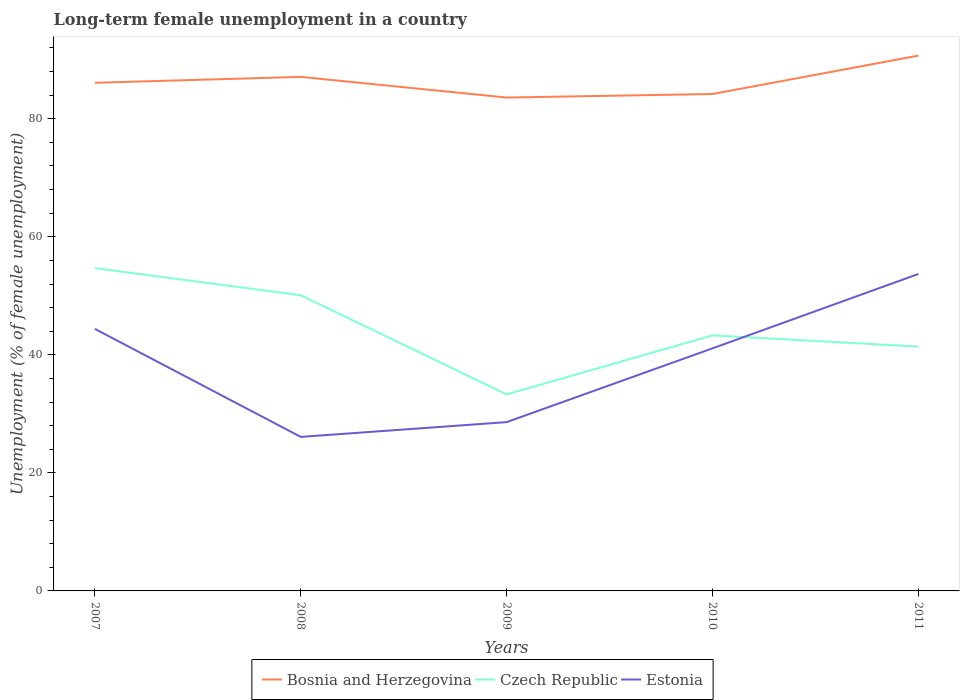Is the number of lines equal to the number of legend labels?
Make the answer very short. Yes. Across all years, what is the maximum percentage of long-term unemployed female population in Czech Republic?
Keep it short and to the point. 33.3. In which year was the percentage of long-term unemployed female population in Bosnia and Herzegovina maximum?
Ensure brevity in your answer.  2009. What is the total percentage of long-term unemployed female population in Estonia in the graph?
Provide a short and direct response. 3.3. What is the difference between the highest and the second highest percentage of long-term unemployed female population in Bosnia and Herzegovina?
Your answer should be compact. 7.1. How many lines are there?
Give a very brief answer. 3. What is the difference between two consecutive major ticks on the Y-axis?
Provide a succinct answer. 20. Are the values on the major ticks of Y-axis written in scientific E-notation?
Make the answer very short. No. Does the graph contain any zero values?
Keep it short and to the point. No. Does the graph contain grids?
Offer a terse response. No. Where does the legend appear in the graph?
Offer a terse response. Bottom center. How many legend labels are there?
Offer a very short reply. 3. How are the legend labels stacked?
Your answer should be compact. Horizontal. What is the title of the graph?
Your response must be concise. Long-term female unemployment in a country. What is the label or title of the Y-axis?
Make the answer very short. Unemployment (% of female unemployment). What is the Unemployment (% of female unemployment) of Bosnia and Herzegovina in 2007?
Provide a short and direct response. 86.1. What is the Unemployment (% of female unemployment) of Czech Republic in 2007?
Provide a succinct answer. 54.7. What is the Unemployment (% of female unemployment) of Estonia in 2007?
Offer a terse response. 44.4. What is the Unemployment (% of female unemployment) of Bosnia and Herzegovina in 2008?
Keep it short and to the point. 87.1. What is the Unemployment (% of female unemployment) in Czech Republic in 2008?
Ensure brevity in your answer.  50.1. What is the Unemployment (% of female unemployment) of Estonia in 2008?
Provide a succinct answer. 26.1. What is the Unemployment (% of female unemployment) in Bosnia and Herzegovina in 2009?
Give a very brief answer. 83.6. What is the Unemployment (% of female unemployment) of Czech Republic in 2009?
Provide a succinct answer. 33.3. What is the Unemployment (% of female unemployment) in Estonia in 2009?
Offer a terse response. 28.6. What is the Unemployment (% of female unemployment) of Bosnia and Herzegovina in 2010?
Provide a short and direct response. 84.2. What is the Unemployment (% of female unemployment) of Czech Republic in 2010?
Provide a short and direct response. 43.3. What is the Unemployment (% of female unemployment) of Estonia in 2010?
Make the answer very short. 41.1. What is the Unemployment (% of female unemployment) in Bosnia and Herzegovina in 2011?
Your response must be concise. 90.7. What is the Unemployment (% of female unemployment) of Czech Republic in 2011?
Provide a succinct answer. 41.4. What is the Unemployment (% of female unemployment) in Estonia in 2011?
Your answer should be compact. 53.7. Across all years, what is the maximum Unemployment (% of female unemployment) of Bosnia and Herzegovina?
Offer a terse response. 90.7. Across all years, what is the maximum Unemployment (% of female unemployment) of Czech Republic?
Offer a terse response. 54.7. Across all years, what is the maximum Unemployment (% of female unemployment) in Estonia?
Offer a terse response. 53.7. Across all years, what is the minimum Unemployment (% of female unemployment) in Bosnia and Herzegovina?
Give a very brief answer. 83.6. Across all years, what is the minimum Unemployment (% of female unemployment) in Czech Republic?
Your response must be concise. 33.3. Across all years, what is the minimum Unemployment (% of female unemployment) in Estonia?
Your response must be concise. 26.1. What is the total Unemployment (% of female unemployment) in Bosnia and Herzegovina in the graph?
Keep it short and to the point. 431.7. What is the total Unemployment (% of female unemployment) of Czech Republic in the graph?
Provide a succinct answer. 222.8. What is the total Unemployment (% of female unemployment) in Estonia in the graph?
Your response must be concise. 193.9. What is the difference between the Unemployment (% of female unemployment) in Bosnia and Herzegovina in 2007 and that in 2008?
Provide a succinct answer. -1. What is the difference between the Unemployment (% of female unemployment) in Czech Republic in 2007 and that in 2008?
Your answer should be compact. 4.6. What is the difference between the Unemployment (% of female unemployment) in Bosnia and Herzegovina in 2007 and that in 2009?
Offer a very short reply. 2.5. What is the difference between the Unemployment (% of female unemployment) of Czech Republic in 2007 and that in 2009?
Make the answer very short. 21.4. What is the difference between the Unemployment (% of female unemployment) of Bosnia and Herzegovina in 2007 and that in 2010?
Your response must be concise. 1.9. What is the difference between the Unemployment (% of female unemployment) of Czech Republic in 2007 and that in 2011?
Ensure brevity in your answer.  13.3. What is the difference between the Unemployment (% of female unemployment) of Bosnia and Herzegovina in 2008 and that in 2009?
Your response must be concise. 3.5. What is the difference between the Unemployment (% of female unemployment) of Czech Republic in 2008 and that in 2009?
Ensure brevity in your answer.  16.8. What is the difference between the Unemployment (% of female unemployment) in Estonia in 2008 and that in 2009?
Give a very brief answer. -2.5. What is the difference between the Unemployment (% of female unemployment) in Bosnia and Herzegovina in 2008 and that in 2010?
Give a very brief answer. 2.9. What is the difference between the Unemployment (% of female unemployment) in Czech Republic in 2008 and that in 2010?
Ensure brevity in your answer.  6.8. What is the difference between the Unemployment (% of female unemployment) in Bosnia and Herzegovina in 2008 and that in 2011?
Your response must be concise. -3.6. What is the difference between the Unemployment (% of female unemployment) of Estonia in 2008 and that in 2011?
Give a very brief answer. -27.6. What is the difference between the Unemployment (% of female unemployment) in Bosnia and Herzegovina in 2009 and that in 2010?
Your response must be concise. -0.6. What is the difference between the Unemployment (% of female unemployment) in Czech Republic in 2009 and that in 2010?
Provide a succinct answer. -10. What is the difference between the Unemployment (% of female unemployment) in Bosnia and Herzegovina in 2009 and that in 2011?
Offer a very short reply. -7.1. What is the difference between the Unemployment (% of female unemployment) of Czech Republic in 2009 and that in 2011?
Offer a very short reply. -8.1. What is the difference between the Unemployment (% of female unemployment) of Estonia in 2009 and that in 2011?
Your answer should be very brief. -25.1. What is the difference between the Unemployment (% of female unemployment) in Bosnia and Herzegovina in 2010 and that in 2011?
Provide a succinct answer. -6.5. What is the difference between the Unemployment (% of female unemployment) in Czech Republic in 2010 and that in 2011?
Provide a short and direct response. 1.9. What is the difference between the Unemployment (% of female unemployment) of Czech Republic in 2007 and the Unemployment (% of female unemployment) of Estonia in 2008?
Keep it short and to the point. 28.6. What is the difference between the Unemployment (% of female unemployment) of Bosnia and Herzegovina in 2007 and the Unemployment (% of female unemployment) of Czech Republic in 2009?
Your answer should be compact. 52.8. What is the difference between the Unemployment (% of female unemployment) of Bosnia and Herzegovina in 2007 and the Unemployment (% of female unemployment) of Estonia in 2009?
Your answer should be very brief. 57.5. What is the difference between the Unemployment (% of female unemployment) in Czech Republic in 2007 and the Unemployment (% of female unemployment) in Estonia in 2009?
Provide a succinct answer. 26.1. What is the difference between the Unemployment (% of female unemployment) of Bosnia and Herzegovina in 2007 and the Unemployment (% of female unemployment) of Czech Republic in 2010?
Your answer should be very brief. 42.8. What is the difference between the Unemployment (% of female unemployment) in Czech Republic in 2007 and the Unemployment (% of female unemployment) in Estonia in 2010?
Give a very brief answer. 13.6. What is the difference between the Unemployment (% of female unemployment) of Bosnia and Herzegovina in 2007 and the Unemployment (% of female unemployment) of Czech Republic in 2011?
Your answer should be very brief. 44.7. What is the difference between the Unemployment (% of female unemployment) of Bosnia and Herzegovina in 2007 and the Unemployment (% of female unemployment) of Estonia in 2011?
Offer a terse response. 32.4. What is the difference between the Unemployment (% of female unemployment) in Bosnia and Herzegovina in 2008 and the Unemployment (% of female unemployment) in Czech Republic in 2009?
Your answer should be compact. 53.8. What is the difference between the Unemployment (% of female unemployment) of Bosnia and Herzegovina in 2008 and the Unemployment (% of female unemployment) of Estonia in 2009?
Offer a very short reply. 58.5. What is the difference between the Unemployment (% of female unemployment) in Czech Republic in 2008 and the Unemployment (% of female unemployment) in Estonia in 2009?
Provide a short and direct response. 21.5. What is the difference between the Unemployment (% of female unemployment) in Bosnia and Herzegovina in 2008 and the Unemployment (% of female unemployment) in Czech Republic in 2010?
Your answer should be compact. 43.8. What is the difference between the Unemployment (% of female unemployment) of Bosnia and Herzegovina in 2008 and the Unemployment (% of female unemployment) of Estonia in 2010?
Your answer should be very brief. 46. What is the difference between the Unemployment (% of female unemployment) in Czech Republic in 2008 and the Unemployment (% of female unemployment) in Estonia in 2010?
Your answer should be compact. 9. What is the difference between the Unemployment (% of female unemployment) in Bosnia and Herzegovina in 2008 and the Unemployment (% of female unemployment) in Czech Republic in 2011?
Offer a very short reply. 45.7. What is the difference between the Unemployment (% of female unemployment) in Bosnia and Herzegovina in 2008 and the Unemployment (% of female unemployment) in Estonia in 2011?
Make the answer very short. 33.4. What is the difference between the Unemployment (% of female unemployment) in Czech Republic in 2008 and the Unemployment (% of female unemployment) in Estonia in 2011?
Keep it short and to the point. -3.6. What is the difference between the Unemployment (% of female unemployment) of Bosnia and Herzegovina in 2009 and the Unemployment (% of female unemployment) of Czech Republic in 2010?
Offer a very short reply. 40.3. What is the difference between the Unemployment (% of female unemployment) of Bosnia and Herzegovina in 2009 and the Unemployment (% of female unemployment) of Estonia in 2010?
Your response must be concise. 42.5. What is the difference between the Unemployment (% of female unemployment) in Czech Republic in 2009 and the Unemployment (% of female unemployment) in Estonia in 2010?
Keep it short and to the point. -7.8. What is the difference between the Unemployment (% of female unemployment) of Bosnia and Herzegovina in 2009 and the Unemployment (% of female unemployment) of Czech Republic in 2011?
Offer a very short reply. 42.2. What is the difference between the Unemployment (% of female unemployment) of Bosnia and Herzegovina in 2009 and the Unemployment (% of female unemployment) of Estonia in 2011?
Give a very brief answer. 29.9. What is the difference between the Unemployment (% of female unemployment) of Czech Republic in 2009 and the Unemployment (% of female unemployment) of Estonia in 2011?
Your answer should be very brief. -20.4. What is the difference between the Unemployment (% of female unemployment) in Bosnia and Herzegovina in 2010 and the Unemployment (% of female unemployment) in Czech Republic in 2011?
Your answer should be compact. 42.8. What is the difference between the Unemployment (% of female unemployment) in Bosnia and Herzegovina in 2010 and the Unemployment (% of female unemployment) in Estonia in 2011?
Provide a succinct answer. 30.5. What is the difference between the Unemployment (% of female unemployment) in Czech Republic in 2010 and the Unemployment (% of female unemployment) in Estonia in 2011?
Keep it short and to the point. -10.4. What is the average Unemployment (% of female unemployment) of Bosnia and Herzegovina per year?
Offer a very short reply. 86.34. What is the average Unemployment (% of female unemployment) of Czech Republic per year?
Provide a succinct answer. 44.56. What is the average Unemployment (% of female unemployment) of Estonia per year?
Ensure brevity in your answer.  38.78. In the year 2007, what is the difference between the Unemployment (% of female unemployment) of Bosnia and Herzegovina and Unemployment (% of female unemployment) of Czech Republic?
Make the answer very short. 31.4. In the year 2007, what is the difference between the Unemployment (% of female unemployment) of Bosnia and Herzegovina and Unemployment (% of female unemployment) of Estonia?
Your answer should be compact. 41.7. In the year 2008, what is the difference between the Unemployment (% of female unemployment) of Bosnia and Herzegovina and Unemployment (% of female unemployment) of Czech Republic?
Your answer should be compact. 37. In the year 2008, what is the difference between the Unemployment (% of female unemployment) in Bosnia and Herzegovina and Unemployment (% of female unemployment) in Estonia?
Provide a succinct answer. 61. In the year 2009, what is the difference between the Unemployment (% of female unemployment) of Bosnia and Herzegovina and Unemployment (% of female unemployment) of Czech Republic?
Keep it short and to the point. 50.3. In the year 2009, what is the difference between the Unemployment (% of female unemployment) of Bosnia and Herzegovina and Unemployment (% of female unemployment) of Estonia?
Offer a very short reply. 55. In the year 2010, what is the difference between the Unemployment (% of female unemployment) in Bosnia and Herzegovina and Unemployment (% of female unemployment) in Czech Republic?
Your response must be concise. 40.9. In the year 2010, what is the difference between the Unemployment (% of female unemployment) of Bosnia and Herzegovina and Unemployment (% of female unemployment) of Estonia?
Your answer should be compact. 43.1. In the year 2011, what is the difference between the Unemployment (% of female unemployment) in Bosnia and Herzegovina and Unemployment (% of female unemployment) in Czech Republic?
Make the answer very short. 49.3. In the year 2011, what is the difference between the Unemployment (% of female unemployment) in Bosnia and Herzegovina and Unemployment (% of female unemployment) in Estonia?
Keep it short and to the point. 37. What is the ratio of the Unemployment (% of female unemployment) of Bosnia and Herzegovina in 2007 to that in 2008?
Keep it short and to the point. 0.99. What is the ratio of the Unemployment (% of female unemployment) of Czech Republic in 2007 to that in 2008?
Offer a terse response. 1.09. What is the ratio of the Unemployment (% of female unemployment) of Estonia in 2007 to that in 2008?
Ensure brevity in your answer.  1.7. What is the ratio of the Unemployment (% of female unemployment) in Bosnia and Herzegovina in 2007 to that in 2009?
Offer a terse response. 1.03. What is the ratio of the Unemployment (% of female unemployment) of Czech Republic in 2007 to that in 2009?
Give a very brief answer. 1.64. What is the ratio of the Unemployment (% of female unemployment) in Estonia in 2007 to that in 2009?
Offer a very short reply. 1.55. What is the ratio of the Unemployment (% of female unemployment) of Bosnia and Herzegovina in 2007 to that in 2010?
Your answer should be compact. 1.02. What is the ratio of the Unemployment (% of female unemployment) in Czech Republic in 2007 to that in 2010?
Keep it short and to the point. 1.26. What is the ratio of the Unemployment (% of female unemployment) in Estonia in 2007 to that in 2010?
Ensure brevity in your answer.  1.08. What is the ratio of the Unemployment (% of female unemployment) in Bosnia and Herzegovina in 2007 to that in 2011?
Offer a very short reply. 0.95. What is the ratio of the Unemployment (% of female unemployment) in Czech Republic in 2007 to that in 2011?
Provide a short and direct response. 1.32. What is the ratio of the Unemployment (% of female unemployment) of Estonia in 2007 to that in 2011?
Keep it short and to the point. 0.83. What is the ratio of the Unemployment (% of female unemployment) of Bosnia and Herzegovina in 2008 to that in 2009?
Offer a very short reply. 1.04. What is the ratio of the Unemployment (% of female unemployment) of Czech Republic in 2008 to that in 2009?
Make the answer very short. 1.5. What is the ratio of the Unemployment (% of female unemployment) of Estonia in 2008 to that in 2009?
Your response must be concise. 0.91. What is the ratio of the Unemployment (% of female unemployment) of Bosnia and Herzegovina in 2008 to that in 2010?
Provide a succinct answer. 1.03. What is the ratio of the Unemployment (% of female unemployment) in Czech Republic in 2008 to that in 2010?
Your response must be concise. 1.16. What is the ratio of the Unemployment (% of female unemployment) of Estonia in 2008 to that in 2010?
Provide a succinct answer. 0.64. What is the ratio of the Unemployment (% of female unemployment) of Bosnia and Herzegovina in 2008 to that in 2011?
Provide a short and direct response. 0.96. What is the ratio of the Unemployment (% of female unemployment) of Czech Republic in 2008 to that in 2011?
Provide a succinct answer. 1.21. What is the ratio of the Unemployment (% of female unemployment) of Estonia in 2008 to that in 2011?
Give a very brief answer. 0.49. What is the ratio of the Unemployment (% of female unemployment) of Bosnia and Herzegovina in 2009 to that in 2010?
Provide a short and direct response. 0.99. What is the ratio of the Unemployment (% of female unemployment) of Czech Republic in 2009 to that in 2010?
Give a very brief answer. 0.77. What is the ratio of the Unemployment (% of female unemployment) in Estonia in 2009 to that in 2010?
Ensure brevity in your answer.  0.7. What is the ratio of the Unemployment (% of female unemployment) of Bosnia and Herzegovina in 2009 to that in 2011?
Keep it short and to the point. 0.92. What is the ratio of the Unemployment (% of female unemployment) in Czech Republic in 2009 to that in 2011?
Give a very brief answer. 0.8. What is the ratio of the Unemployment (% of female unemployment) in Estonia in 2009 to that in 2011?
Keep it short and to the point. 0.53. What is the ratio of the Unemployment (% of female unemployment) of Bosnia and Herzegovina in 2010 to that in 2011?
Provide a short and direct response. 0.93. What is the ratio of the Unemployment (% of female unemployment) in Czech Republic in 2010 to that in 2011?
Provide a succinct answer. 1.05. What is the ratio of the Unemployment (% of female unemployment) in Estonia in 2010 to that in 2011?
Provide a succinct answer. 0.77. What is the difference between the highest and the second highest Unemployment (% of female unemployment) of Bosnia and Herzegovina?
Provide a short and direct response. 3.6. What is the difference between the highest and the second highest Unemployment (% of female unemployment) in Estonia?
Offer a very short reply. 9.3. What is the difference between the highest and the lowest Unemployment (% of female unemployment) of Bosnia and Herzegovina?
Your answer should be very brief. 7.1. What is the difference between the highest and the lowest Unemployment (% of female unemployment) of Czech Republic?
Give a very brief answer. 21.4. What is the difference between the highest and the lowest Unemployment (% of female unemployment) in Estonia?
Provide a succinct answer. 27.6. 